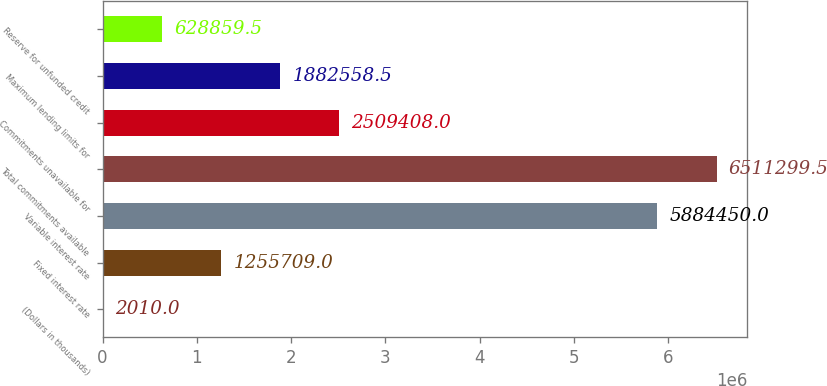<chart> <loc_0><loc_0><loc_500><loc_500><bar_chart><fcel>(Dollars in thousands)<fcel>Fixed interest rate<fcel>Variable interest rate<fcel>Total commitments available<fcel>Commitments unavailable for<fcel>Maximum lending limits for<fcel>Reserve for unfunded credit<nl><fcel>2010<fcel>1.25571e+06<fcel>5.88445e+06<fcel>6.5113e+06<fcel>2.50941e+06<fcel>1.88256e+06<fcel>628860<nl></chart> 